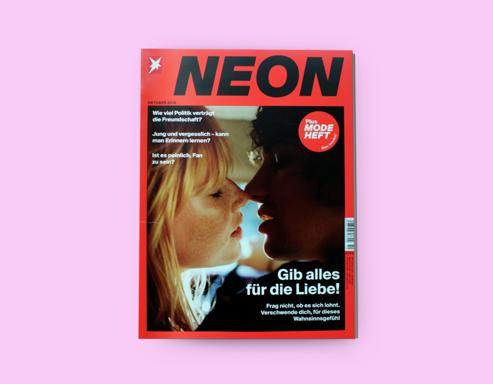What might the close-up image of two faces about to kiss signify in relation to the magazine's content? The close-up shot of two faces about to kiss captures a moment full of potential and intimacy. It signifies a focus on human emotion and personal stories. In relation to the magazine's content, it likely indicates that the issue contains articles about relationships, love, and connecting with others on a deep level, aligning with the overarching theme suggested by the cover's headline. 